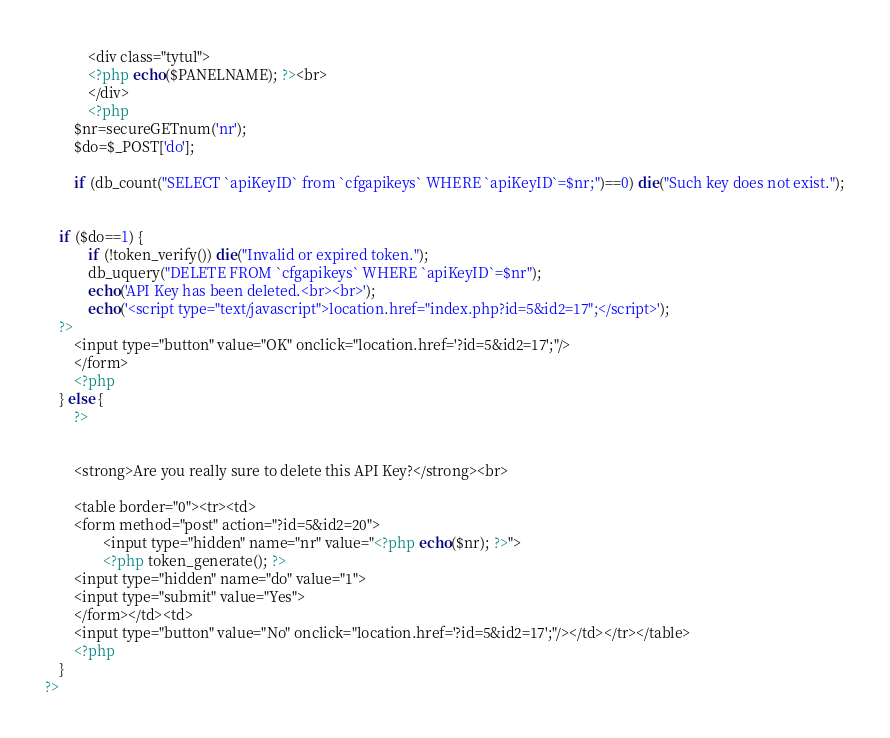<code> <loc_0><loc_0><loc_500><loc_500><_PHP_>		    <div class="tytul">
			<?php echo($PANELNAME); ?><br>
		    </div>
		    <?php
		$nr=secureGETnum('nr');
		$do=$_POST['do'];		

		if (db_count("SELECT `apiKeyID` from `cfgapikeys` WHERE `apiKeyID`=$nr;")==0) die("Such key does not exist.");
		
		
	if ($do==1) {
            if (!token_verify()) die("Invalid or expired token.");
			db_uquery("DELETE FROM `cfgapikeys` WHERE `apiKeyID`=$nr");
			echo('API Key has been deleted.<br><br>');
			echo('<script type="text/javascript">location.href="index.php?id=5&id2=17";</script>');
	?>
		<input type="button" value="OK" onclick="location.href='?id=5&id2=17';"/>
		</form>
		<?php
	} else {
		?>
		
		
		<strong>Are you really sure to delete this API Key?</strong><br>

		<table border="0"><tr><td>
		<form method="post" action="?id=5&id2=20">
                <input type="hidden" name="nr" value="<?php echo($nr); ?>">
                <?php token_generate(); ?>
		<input type="hidden" name="do" value="1">
		<input type="submit" value="Yes">
		</form></td><td>
		<input type="button" value="No" onclick="location.href='?id=5&id2=17';"/></td></tr></table>
		<?php
	}
?></code> 